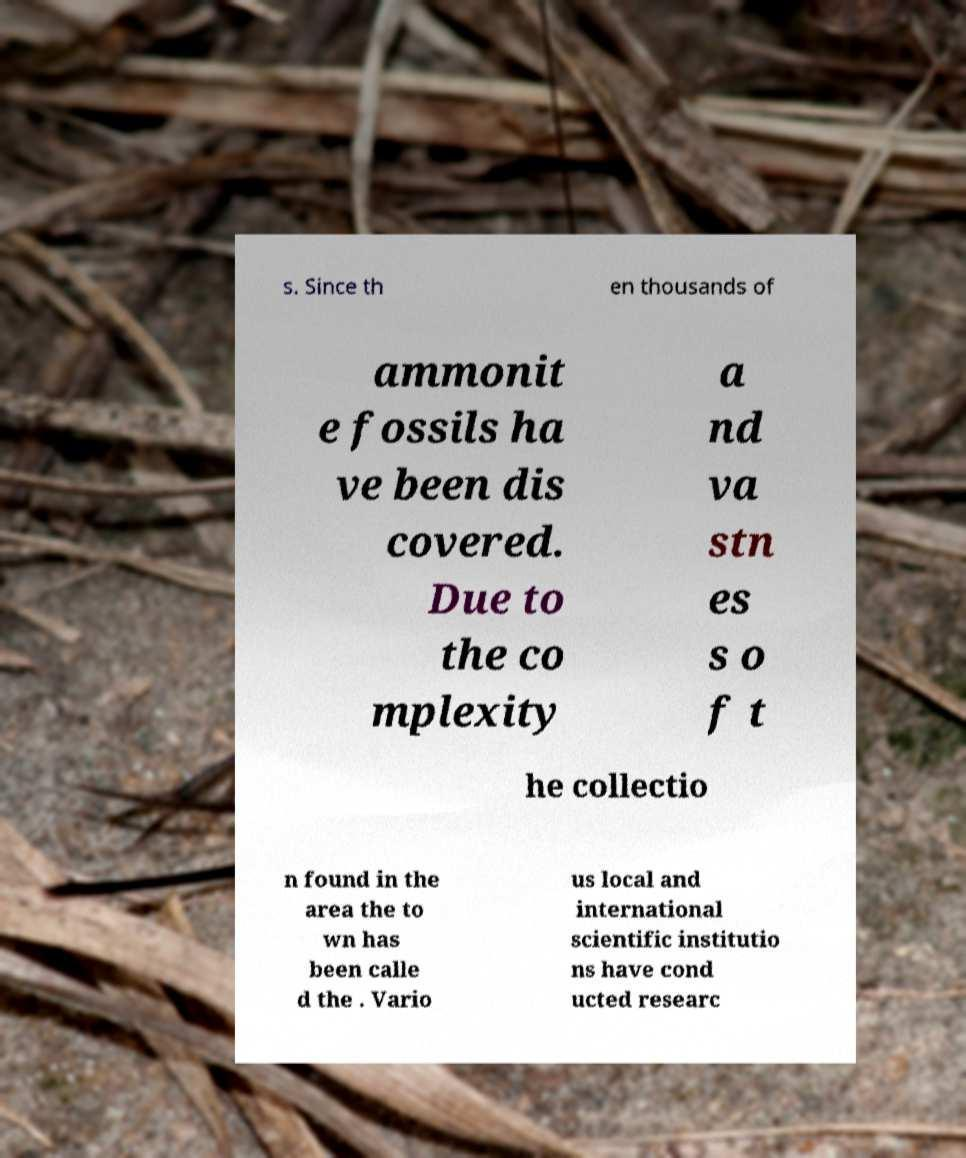There's text embedded in this image that I need extracted. Can you transcribe it verbatim? s. Since th en thousands of ammonit e fossils ha ve been dis covered. Due to the co mplexity a nd va stn es s o f t he collectio n found in the area the to wn has been calle d the . Vario us local and international scientific institutio ns have cond ucted researc 